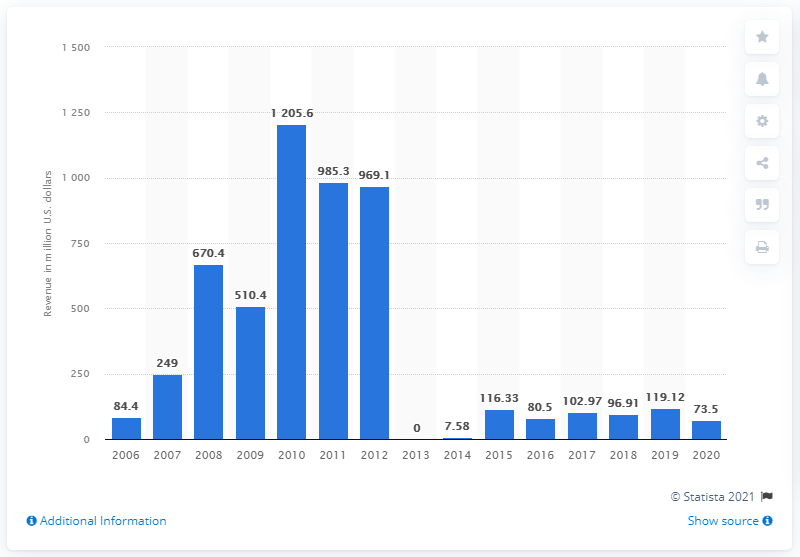Point out several critical features in this image. In 2020, ReneSola's revenue was approximately 73.5 million. ReneSola's revenue in the previous year was 119.12 million. 